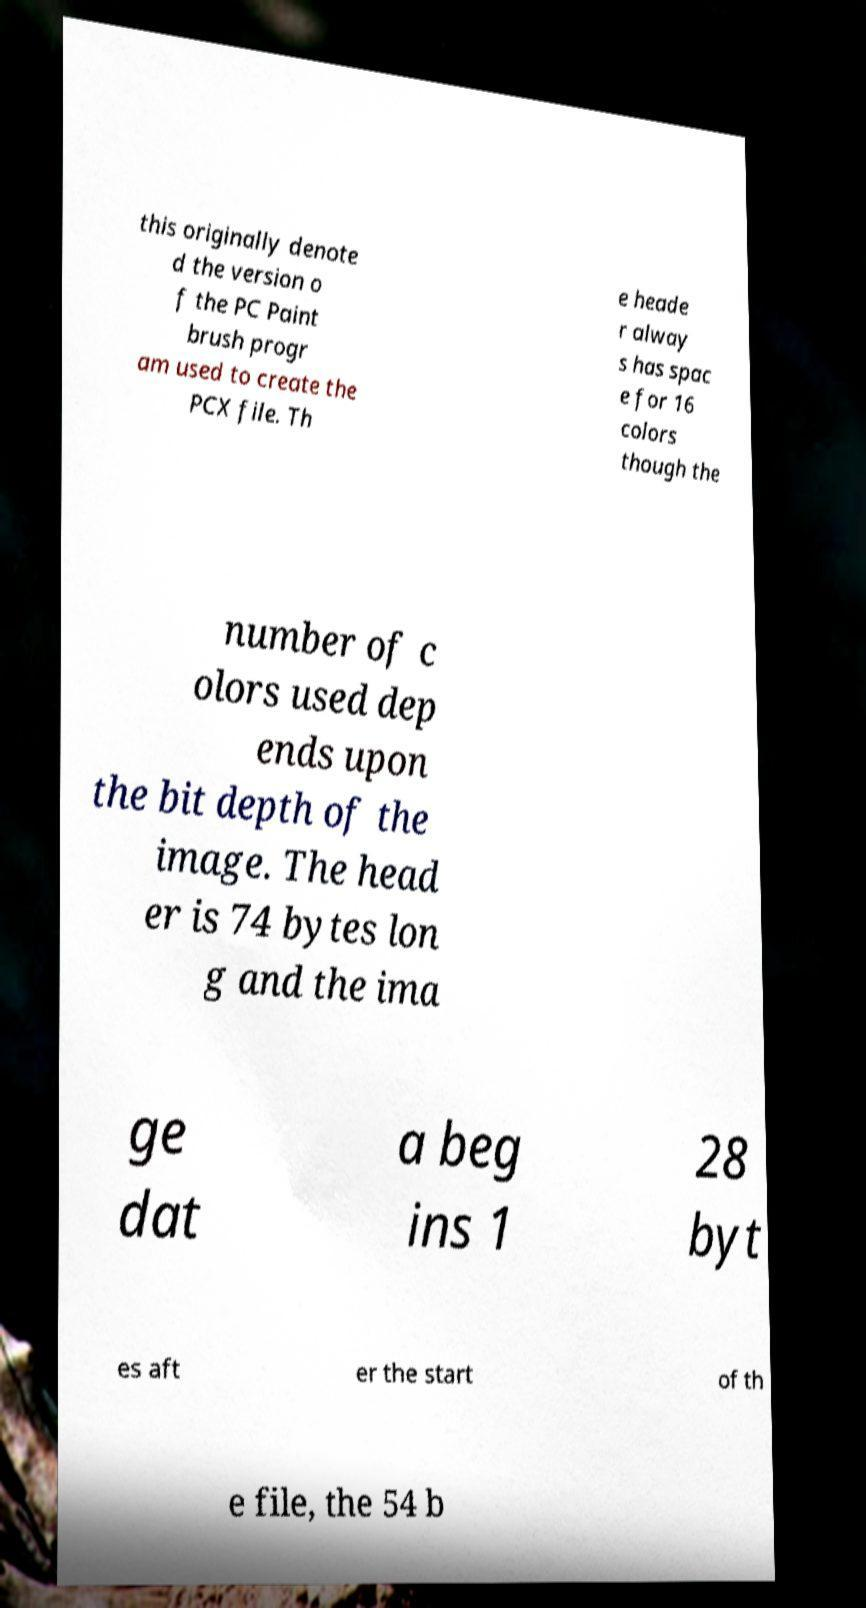Could you assist in decoding the text presented in this image and type it out clearly? this originally denote d the version o f the PC Paint brush progr am used to create the PCX file. Th e heade r alway s has spac e for 16 colors though the number of c olors used dep ends upon the bit depth of the image. The head er is 74 bytes lon g and the ima ge dat a beg ins 1 28 byt es aft er the start of th e file, the 54 b 